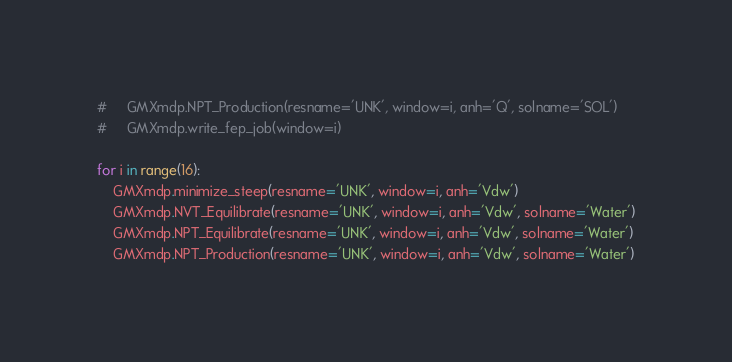<code> <loc_0><loc_0><loc_500><loc_500><_Python_>#     GMXmdp.NPT_Production(resname='UNK', window=i, anh='Q', solname='SOL')
#     GMXmdp.write_fep_job(window=i)

for i in range(16):
    GMXmdp.minimize_steep(resname='UNK', window=i, anh='Vdw')
    GMXmdp.NVT_Equilibrate(resname='UNK', window=i, anh='Vdw', solname='Water')
    GMXmdp.NPT_Equilibrate(resname='UNK', window=i, anh='Vdw', solname='Water')
    GMXmdp.NPT_Production(resname='UNK', window=i, anh='Vdw', solname='Water')</code> 